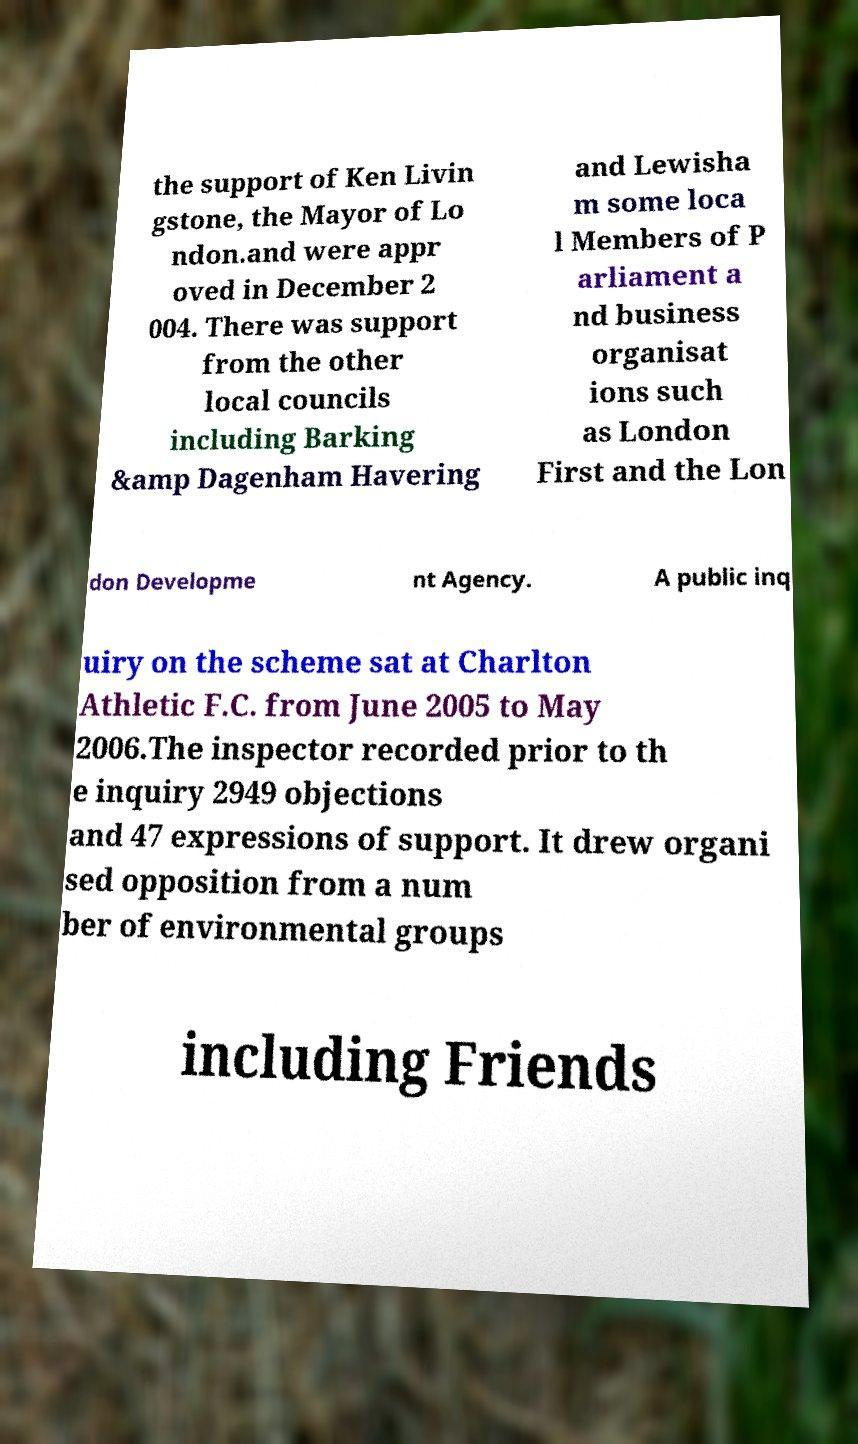Can you accurately transcribe the text from the provided image for me? the support of Ken Livin gstone, the Mayor of Lo ndon.and were appr oved in December 2 004. There was support from the other local councils including Barking &amp Dagenham Havering and Lewisha m some loca l Members of P arliament a nd business organisat ions such as London First and the Lon don Developme nt Agency. A public inq uiry on the scheme sat at Charlton Athletic F.C. from June 2005 to May 2006.The inspector recorded prior to th e inquiry 2949 objections and 47 expressions of support. It drew organi sed opposition from a num ber of environmental groups including Friends 